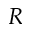<formula> <loc_0><loc_0><loc_500><loc_500>R</formula> 